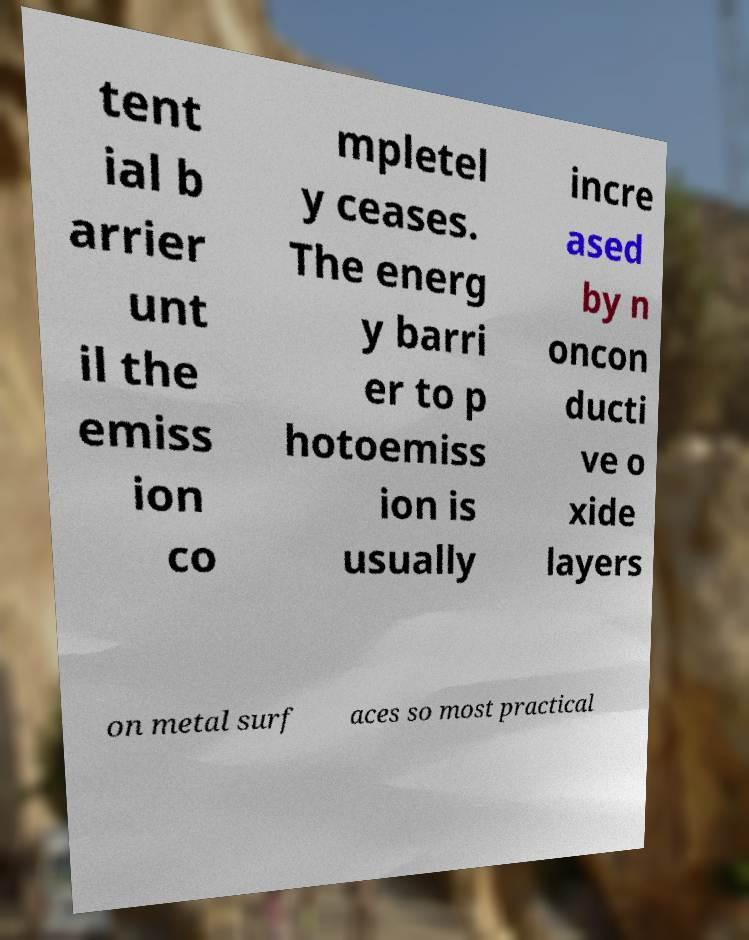For documentation purposes, I need the text within this image transcribed. Could you provide that? tent ial b arrier unt il the emiss ion co mpletel y ceases. The energ y barri er to p hotoemiss ion is usually incre ased by n oncon ducti ve o xide layers on metal surf aces so most practical 